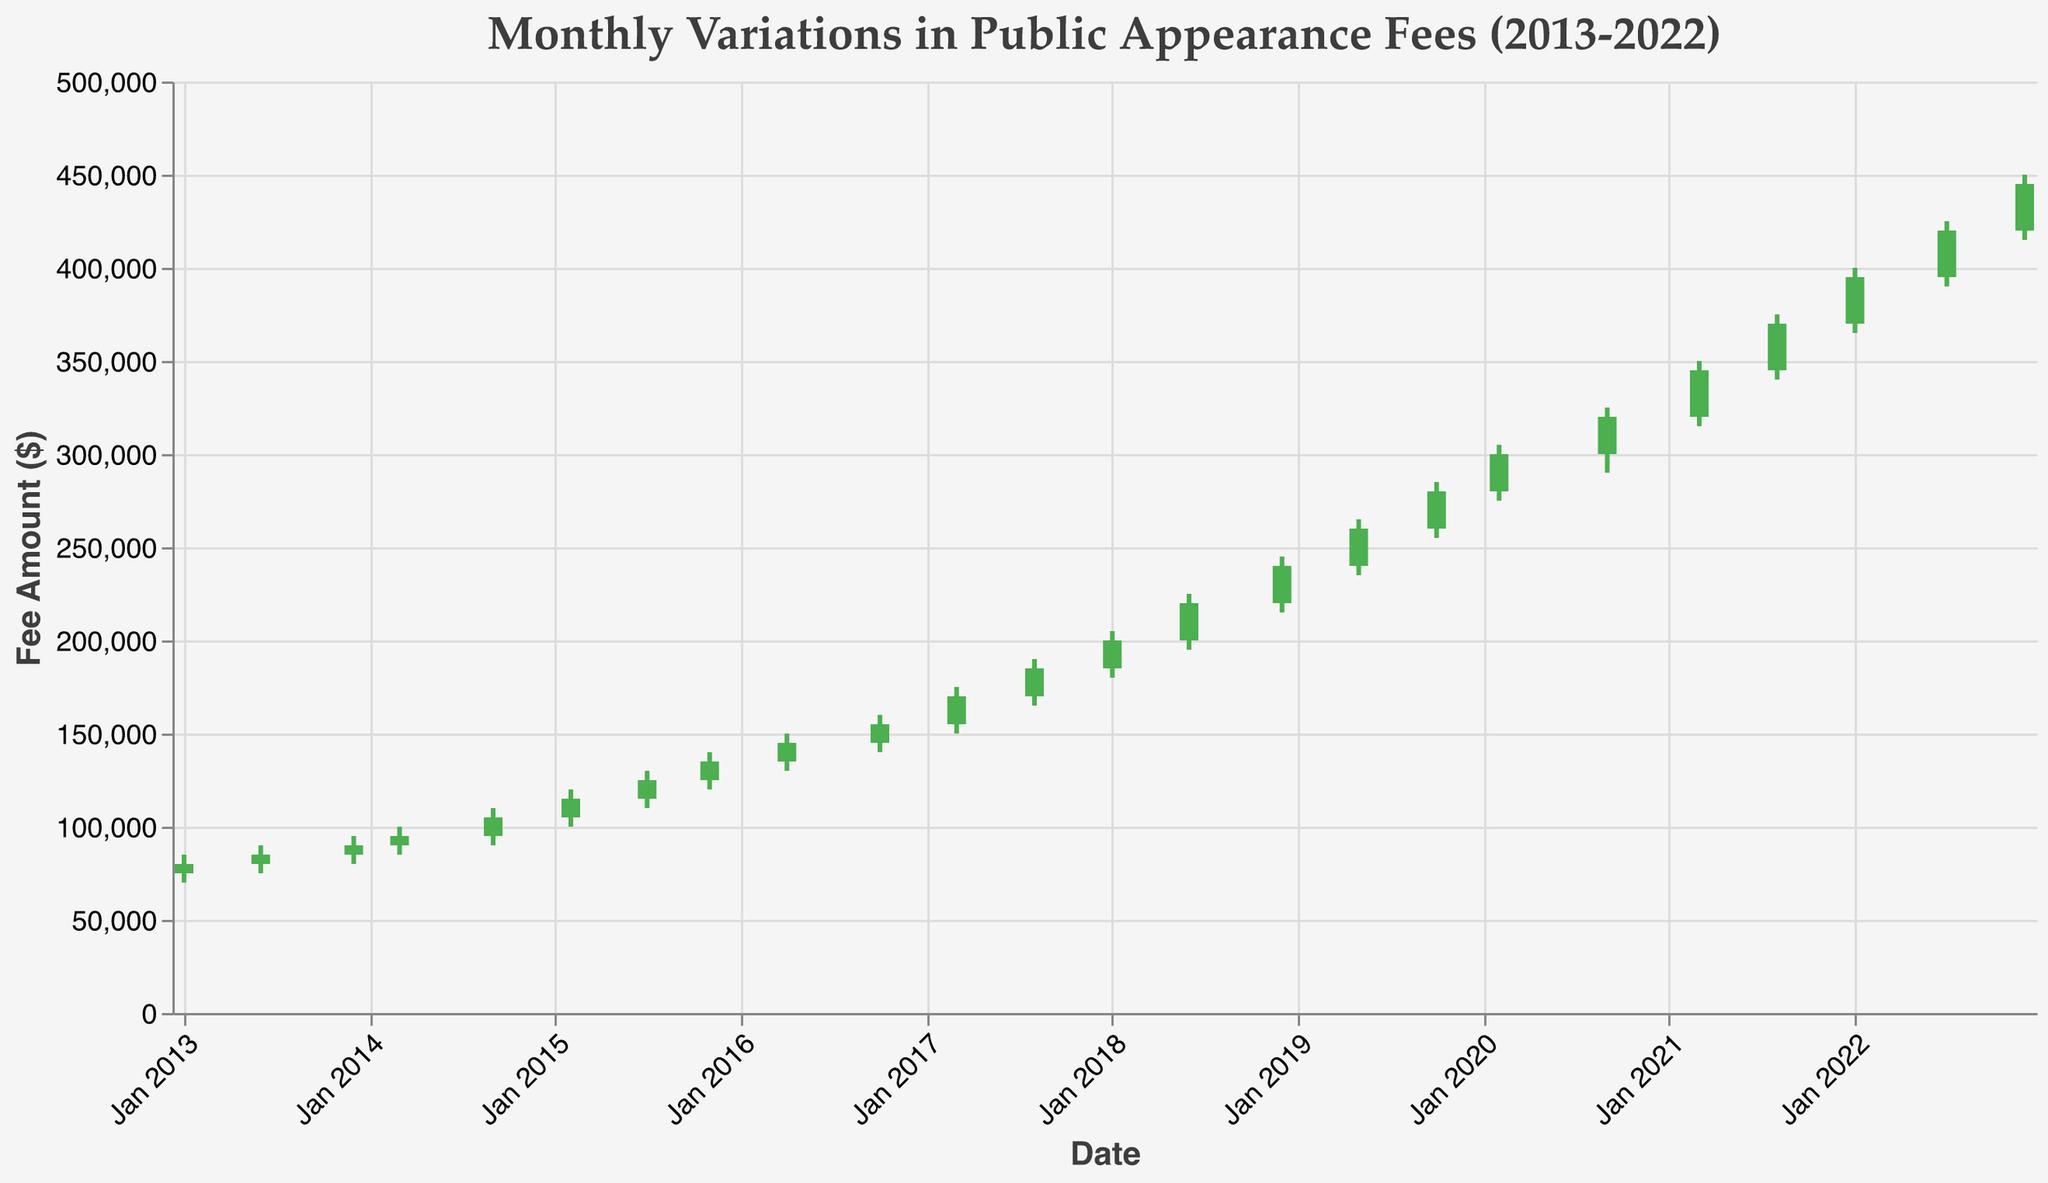What is the highest fee amount recorded in 2022? The highest fee amount recorded in 2022 is 450000 as seen in December.
Answer: 450000 Which month had the lowest fee amount in 2013? Looking at the chart, January 2013 had the lowest fee amount with the low value being 70000.
Answer: January 2013 What was the closing fee in March 2017? The closing fee for March 2017 is 170000 as indicated in the chart.
Answer: 170000 How many data points show a decrease in closing fees compared to the opening fees? We look at the colors, green bars represent an increase in fee while red bars represent a decrease. No green bars signify a decrease in closing fees, so there are no data points where closing fees are less than opening fees.
Answer: 0 Which month had the highest difference between the high and low fees in 2018? To find the month with the highest difference between high and low fees in 2018, we calculate the differences for January (25000), June (30000), and December (30000). Both June and December have the highest difference of 30000.
Answer: June 2018 and December 2018 What is the trend in public appearance fees from Jan 2013 to Dec 2013? By observing the opening and closing fees from Jan 2013 to Dec 2013, there is a steady increase. Starting from 75000 in Jan and ending at 90000 in Dec.
Answer: Increasing What is the average closing fee for the year 2015? The closing fees for 2015 are: Feb (115000), Jul (125000), and Nov (135000). Summing these up yields 375000, and the average is 375000 / 3 = 125000.
Answer: 125000 Which year shows the highest growth in public appearance fees? To find the highest growth, calculate the difference from the start to the end of each year and compare. 2020 shows high growth from 300000 in September to 345000 in March 2021.
Answer: 2020 In which year did the fee cross the 300000 mark for the first time? The fee amount crosses 300000 for the first time in 2020, in February.
Answer: 2020 What is the total sum of the closing fees for 2018? The closing fees for 2018 are 200000 (Jan), 220000 (Jun), and 240000 (Dec). Summing these up yields 660000.
Answer: 660000 